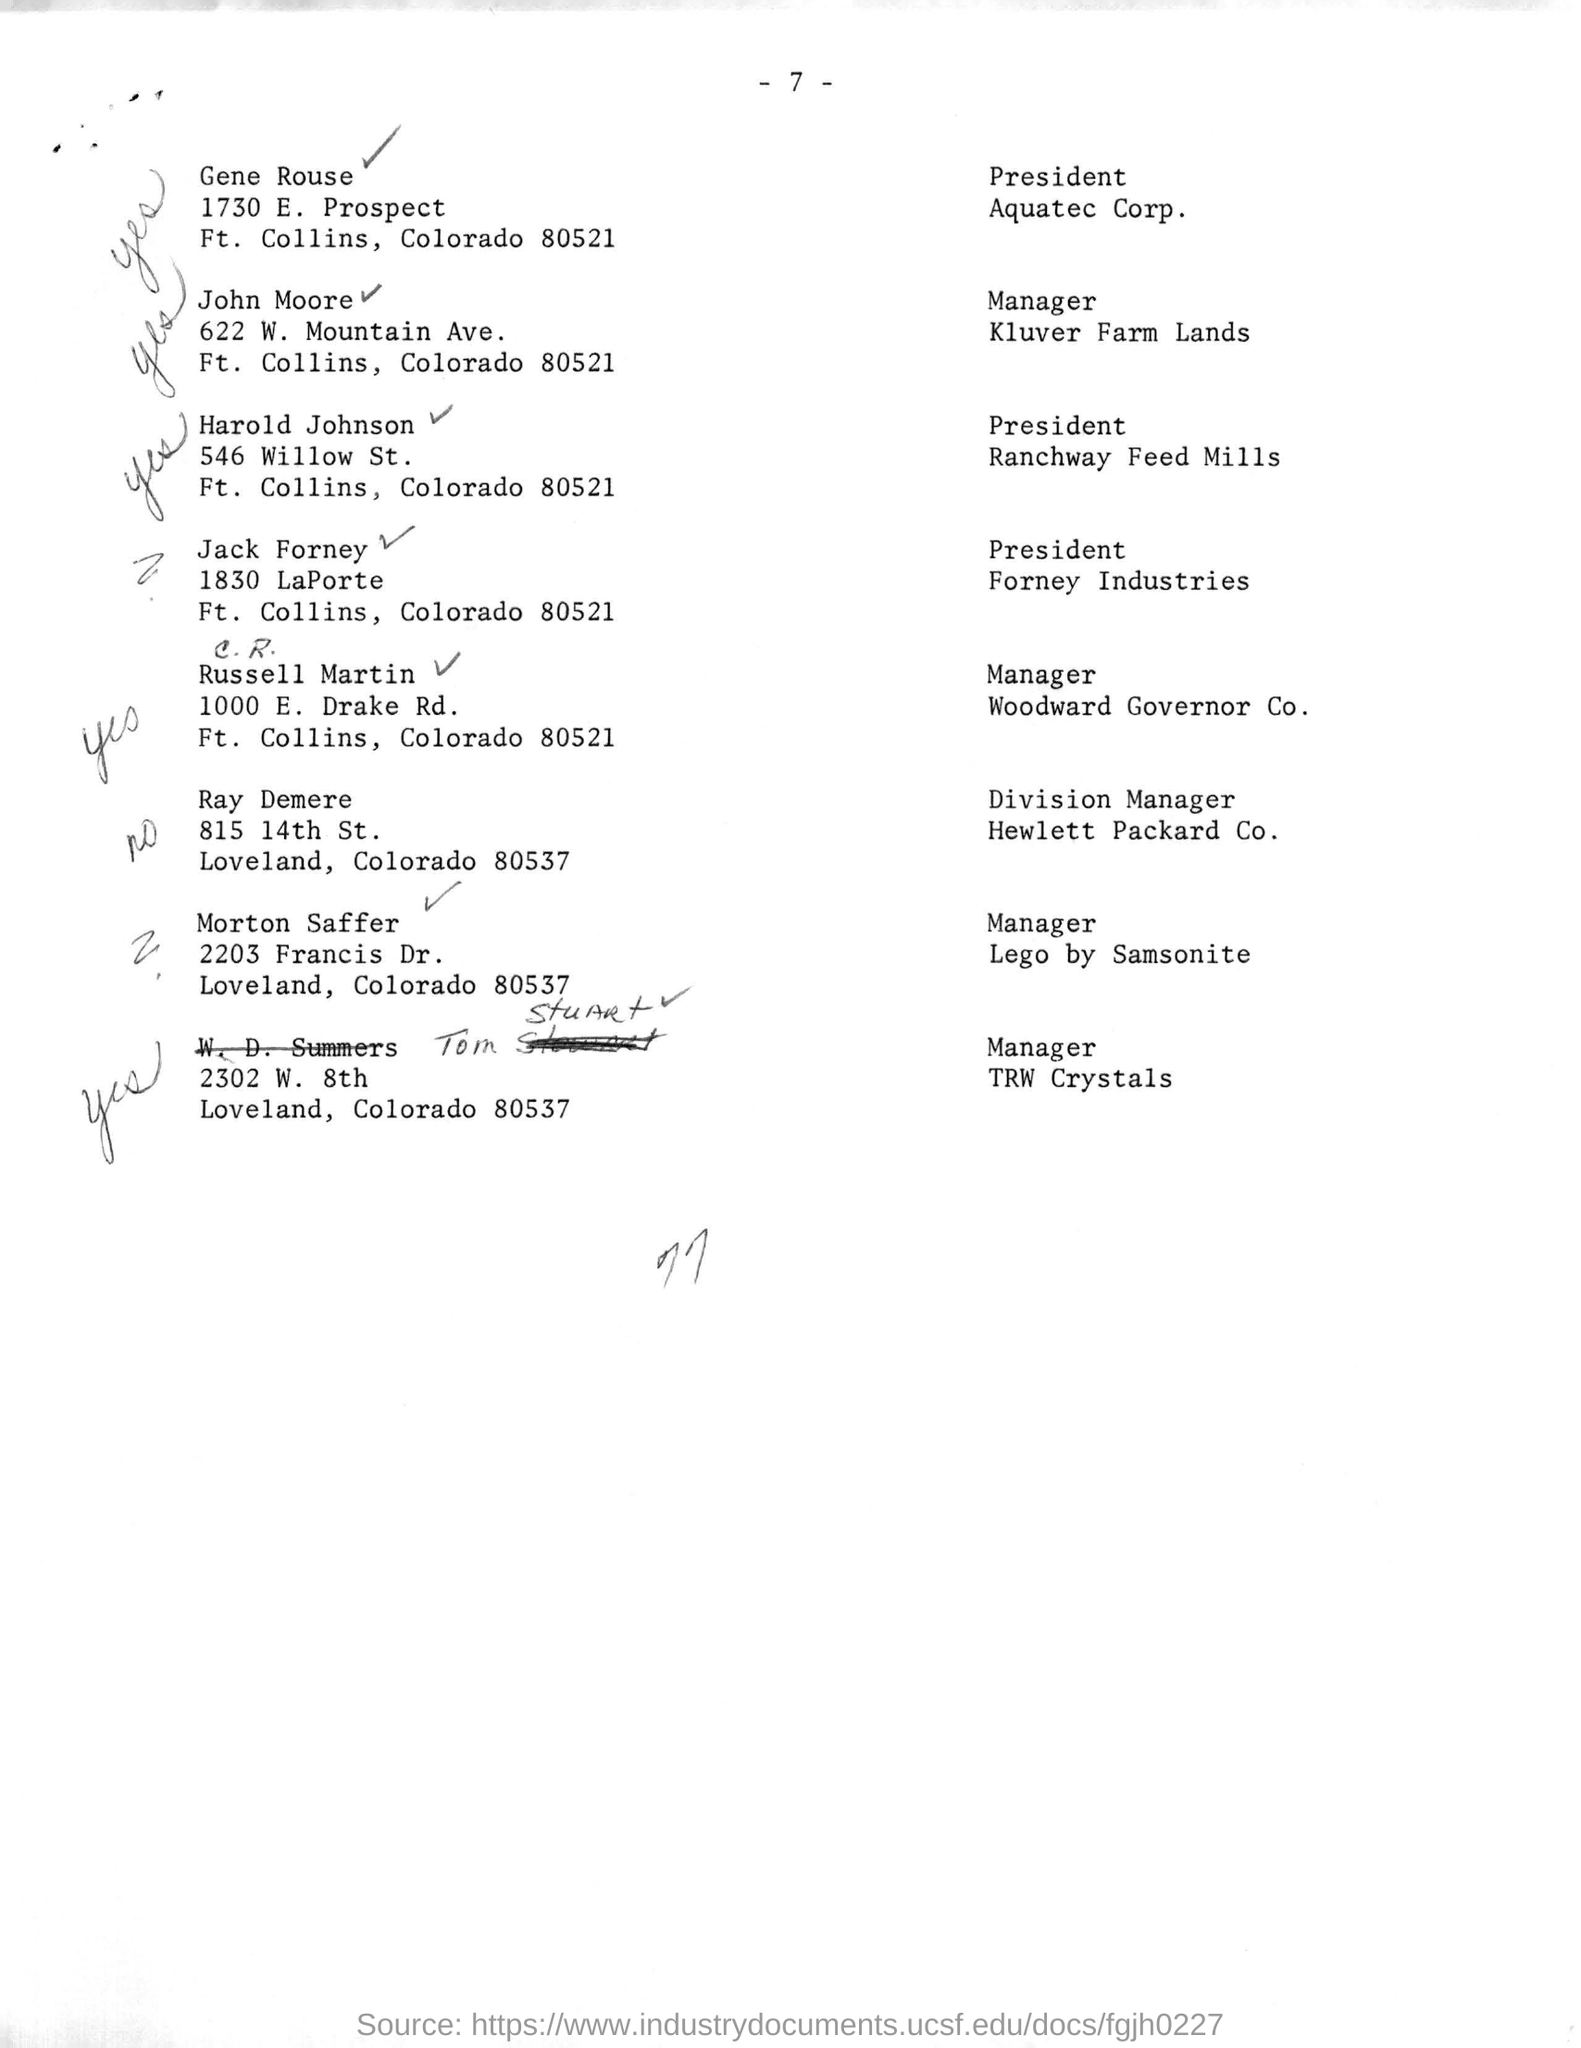Indicate a few pertinent items in this graphic. The postal code of Loveland is 80537. The president of Aquatec Corp. is named Gene Rouse. Ray Demere is the Division Manager. 